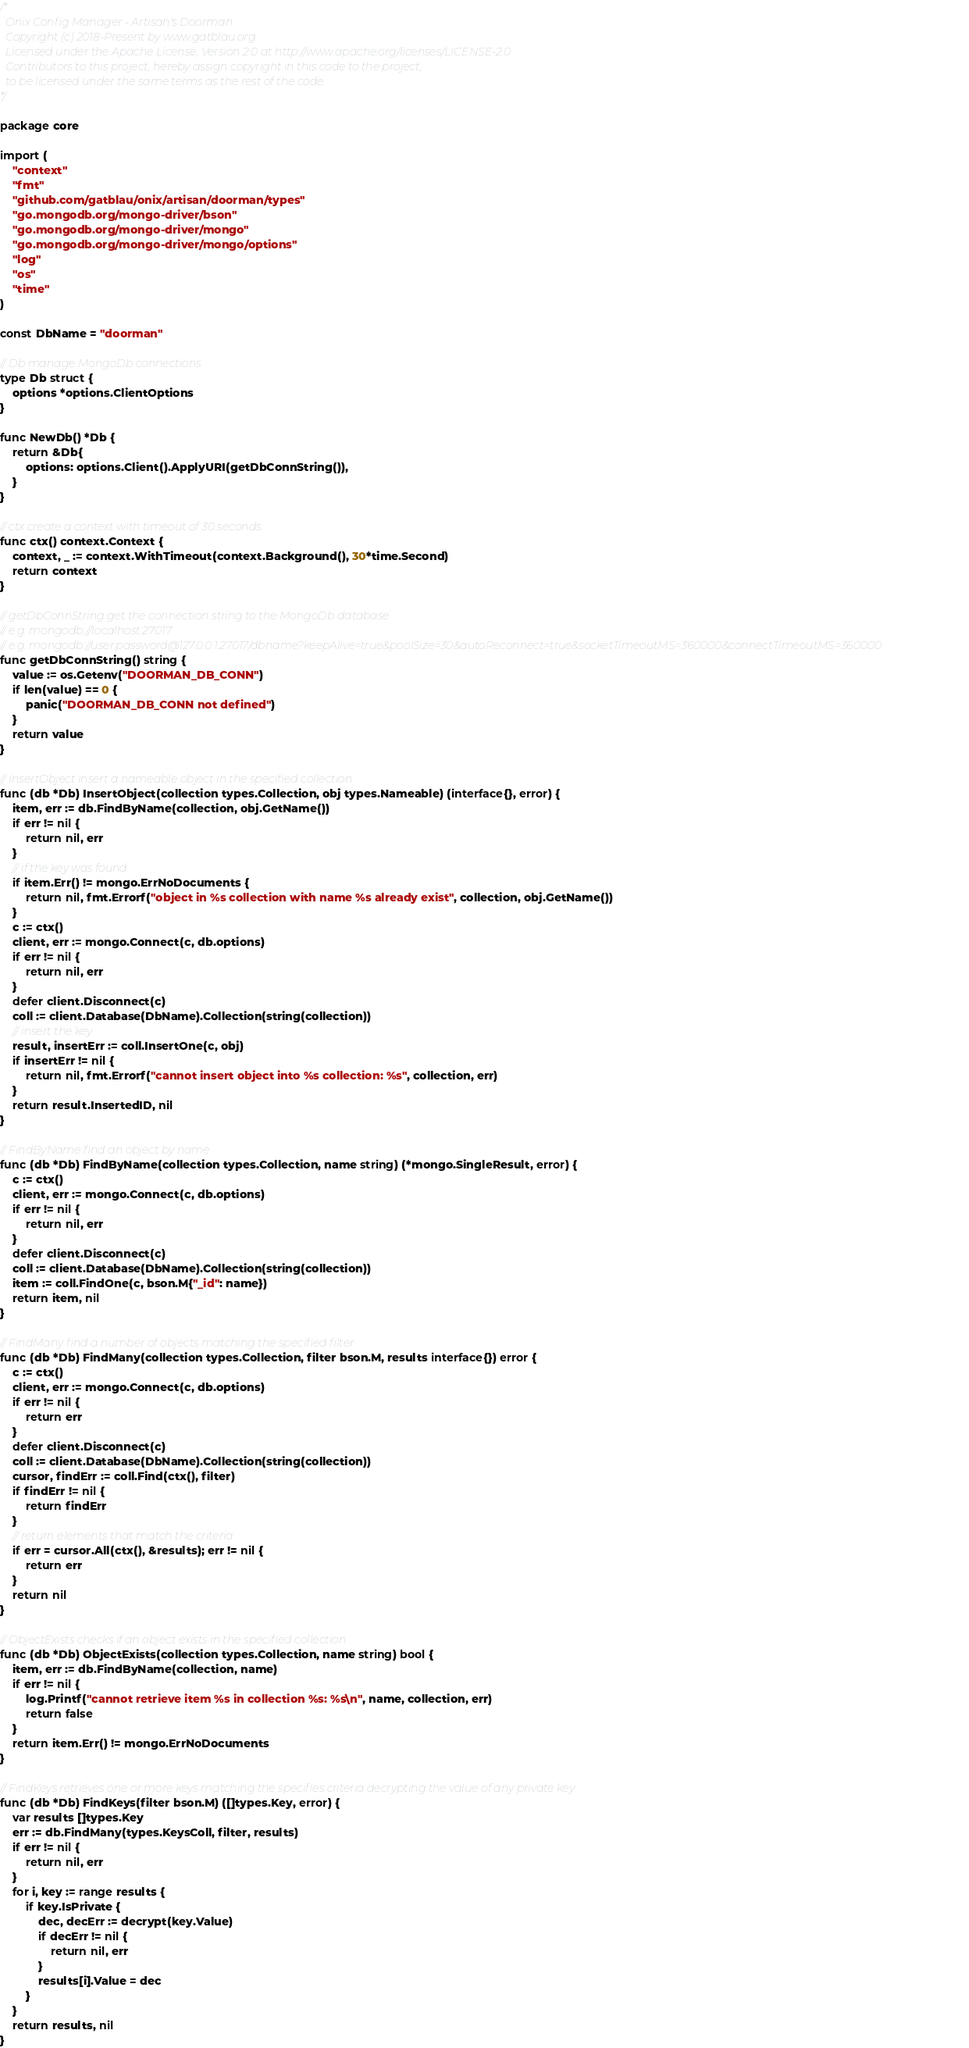<code> <loc_0><loc_0><loc_500><loc_500><_Go_>/*
  Onix Config Manager - Artisan's Doorman
  Copyright (c) 2018-Present by www.gatblau.org
  Licensed under the Apache License, Version 2.0 at http://www.apache.org/licenses/LICENSE-2.0
  Contributors to this project, hereby assign copyright in this code to the project,
  to be licensed under the same terms as the rest of the code.
*/

package core

import (
	"context"
	"fmt"
	"github.com/gatblau/onix/artisan/doorman/types"
	"go.mongodb.org/mongo-driver/bson"
	"go.mongodb.org/mongo-driver/mongo"
	"go.mongodb.org/mongo-driver/mongo/options"
	"log"
	"os"
	"time"
)

const DbName = "doorman"

// Db manage MongoDb connections
type Db struct {
	options *options.ClientOptions
}

func NewDb() *Db {
	return &Db{
		options: options.Client().ApplyURI(getDbConnString()),
	}
}

// ctx create a context with timeout of 30 seconds
func ctx() context.Context {
	context, _ := context.WithTimeout(context.Background(), 30*time.Second)
	return context
}

// getDbConnString get the connection string to the MongoDb database
// e.g. mongodb://localhost:27017
// e.g. mongodb://user:password@127.0.0.1:27017/dbname?keepAlive=true&poolSize=30&autoReconnect=true&socketTimeoutMS=360000&connectTimeoutMS=360000
func getDbConnString() string {
	value := os.Getenv("DOORMAN_DB_CONN")
	if len(value) == 0 {
		panic("DOORMAN_DB_CONN not defined")
	}
	return value
}

// InsertObject insert a nameable object in the specified collection
func (db *Db) InsertObject(collection types.Collection, obj types.Nameable) (interface{}, error) {
	item, err := db.FindByName(collection, obj.GetName())
	if err != nil {
		return nil, err
	}
	// if the key was found
	if item.Err() != mongo.ErrNoDocuments {
		return nil, fmt.Errorf("object in %s collection with name %s already exist", collection, obj.GetName())
	}
	c := ctx()
	client, err := mongo.Connect(c, db.options)
	if err != nil {
		return nil, err
	}
	defer client.Disconnect(c)
	coll := client.Database(DbName).Collection(string(collection))
	// insert the key
	result, insertErr := coll.InsertOne(c, obj)
	if insertErr != nil {
		return nil, fmt.Errorf("cannot insert object into %s collection: %s", collection, err)
	}
	return result.InsertedID, nil
}

// FindByName find an object by name
func (db *Db) FindByName(collection types.Collection, name string) (*mongo.SingleResult, error) {
	c := ctx()
	client, err := mongo.Connect(c, db.options)
	if err != nil {
		return nil, err
	}
	defer client.Disconnect(c)
	coll := client.Database(DbName).Collection(string(collection))
	item := coll.FindOne(c, bson.M{"_id": name})
	return item, nil
}

// FindMany find a number of objects matching the specified filter
func (db *Db) FindMany(collection types.Collection, filter bson.M, results interface{}) error {
	c := ctx()
	client, err := mongo.Connect(c, db.options)
	if err != nil {
		return err
	}
	defer client.Disconnect(c)
	coll := client.Database(DbName).Collection(string(collection))
	cursor, findErr := coll.Find(ctx(), filter)
	if findErr != nil {
		return findErr
	}
	// return elements that match the criteria
	if err = cursor.All(ctx(), &results); err != nil {
		return err
	}
	return nil
}

// ObjectExists checks if an object exists in the specified collection
func (db *Db) ObjectExists(collection types.Collection, name string) bool {
	item, err := db.FindByName(collection, name)
	if err != nil {
		log.Printf("cannot retrieve item %s in collection %s: %s\n", name, collection, err)
		return false
	}
	return item.Err() != mongo.ErrNoDocuments
}

// FindKeys retrieves one or more keys matching the specifies criteria decrypting the value of any private key
func (db *Db) FindKeys(filter bson.M) ([]types.Key, error) {
	var results []types.Key
	err := db.FindMany(types.KeysColl, filter, results)
	if err != nil {
		return nil, err
	}
	for i, key := range results {
		if key.IsPrivate {
			dec, decErr := decrypt(key.Value)
			if decErr != nil {
				return nil, err
			}
			results[i].Value = dec
		}
	}
	return results, nil
}
</code> 